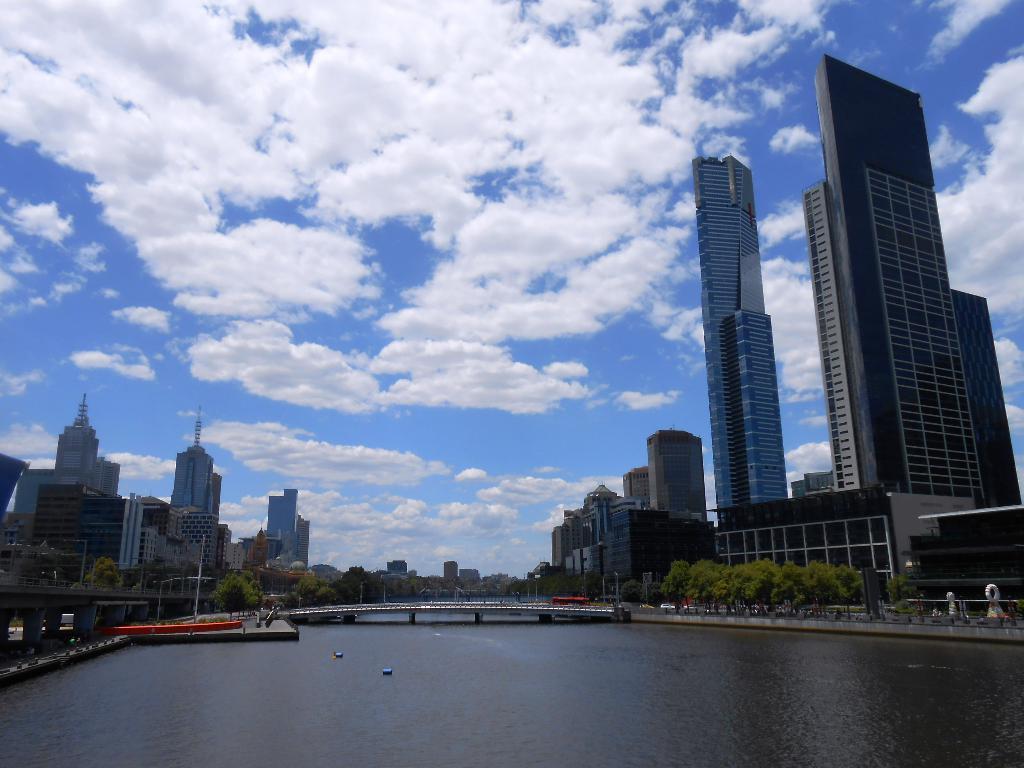Describe this image in one or two sentences. In this image there is a big river with bridge on it, also there are so many trees and buildings beside that. 